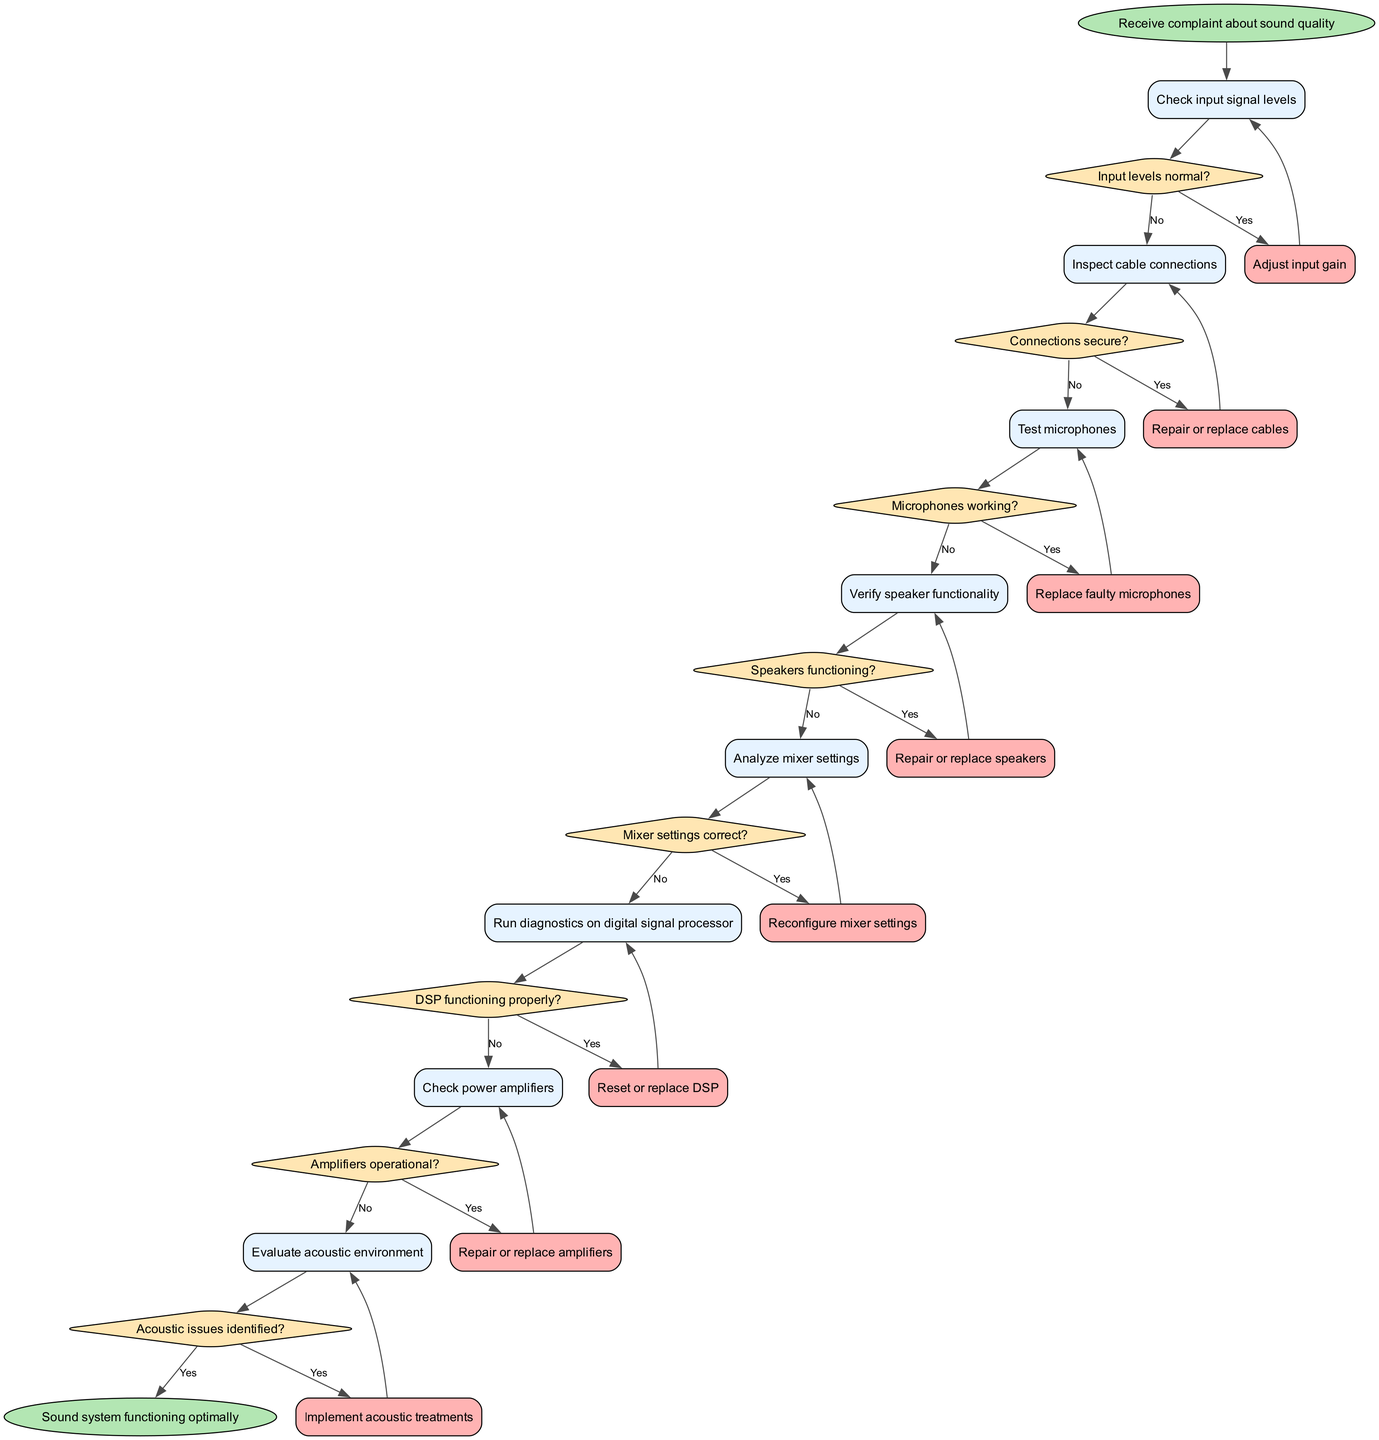What is the starting point of the diagram? The starting point of the diagram is the node titled "Receive complaint about sound quality." This is typically represented as the first node that flows into the process.
Answer: Receive complaint about sound quality How many activities are listed in the diagram? The diagram contains eight activities, which are represented as distinct nodes leading to decision points. Each activity is sequentially connected to a decision point.
Answer: Eight What is the first decision made in the troubleshooting process? The first decision made is "Input levels normal?" This decision follows the initial activity of checking input signal levels and indicates whether the next steps are required.
Answer: Input levels normal? What action is taken if the input levels are not normal? If the input levels are not normal, the action taken is "Adjust input gain." This is the response defined in the flow of the diagram after checking the input signal levels.
Answer: Adjust input gain What is the end point of the diagram? The end point of the diagram is "Sound system functioning optimally.” This signifies that all necessary troubleshooting has been completed successfully, leading to optimal functionality.
Answer: Sound system functioning optimally Which activity leads to the decision "Microphones working?" The activity that leads to the decision "Microphones working?" is "Test microphones." This is the direct precursor activity before the decision point regarding microphone functionality.
Answer: Test microphones What happens if the speakers are not functioning? If the speakers are not functioning, the action taken is "Repair or replace speakers." This response is outlined in the flow that occurs after determining the functionality of the speakers.
Answer: Repair or replace speakers How many decision points are in the diagram? There are eight decision points in total, each corresponding to one of the activities listed in the diagram. Each decision checks the status of a specific component of the sound system.
Answer: Eight What is the action to be taken if acoustic issues are identified? If acoustic issues are identified, the action is "Implement acoustic treatments." This suggests a step taken when the evaluation of the acoustic environment reveals problems.
Answer: Implement acoustic treatments 